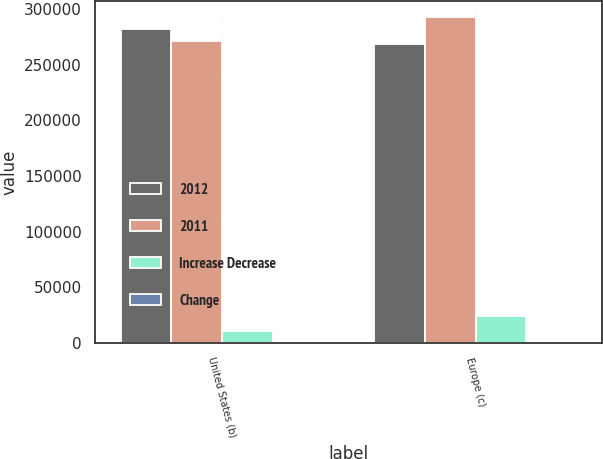Convert chart. <chart><loc_0><loc_0><loc_500><loc_500><stacked_bar_chart><ecel><fcel>United States (b)<fcel>Europe (c)<nl><fcel>2012<fcel>281974<fcel>268299<nl><fcel>2011<fcel>271029<fcel>292533<nl><fcel>Increase Decrease<fcel>10945<fcel>24234<nl><fcel>Change<fcel>4<fcel>8.3<nl></chart> 